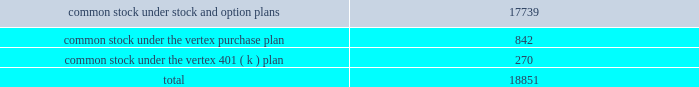"distribution date" ) .
Until the distribution date ( or earlier redemption or expiration of the rights ) , the rights will be traded with , and only with , the common stock .
Until a right is exercised , the right will not entitle the holder thereof to any rights as a stockholder .
If any person or group becomes an acquiring person , each holder of a right , other than rights beneficially owned by the acquiring person , will thereafter have the right to receive upon exercise and payment of the purchase price that number of shares of common stock having a market value of two times the purchase price and , if the company is acquired in a business combination transaction or 50% ( 50 % ) or more of its assets are sold , each holder of a right will thereafter have the right to receive upon exercise and payment of the purchase price that number of shares of common stock of the acquiring company which at the time of the transaction will have a market value of two times the purchase price .
At any time after any person becomes an acquiring person and prior to the acquisition by such person or group of 50% ( 50 % ) or more of the outstanding common stock , the board of directors of the company may cause the rights ( other than rights owned by such person or group ) to be exchanged , in whole or in part , for common stock or junior preferred shares , at an exchange rate of one share of common stock per right or one half of one-hundredth of a junior preferred share per right .
At any time prior to the acquisition by a person or group of beneficial ownership of 15% ( 15 % ) or more of the outstanding common stock , the board of directors of the company may redeem the rights at a price of $ 0.01 per right .
The rights have certain anti-takeover effects , in that they will cause substantial dilution to a person or group that attempts to acquire a significant interest in vertex on terms not approved by the board of directors .
Common stock reserved for future issuance at december 31 , 2005 , the company has reserved shares of common stock for future issuance under all equity compensation plans as follows ( shares in thousands ) : o .
Significant revenue arrangements the company has formed strategic collaborations with pharmaceutical companies and other organizations in the areas of drug discovery , development , and commercialization .
Research , development and commercialization agreements provide the company with financial support and other valuable resources for its research programs and for the development of clinical drug candidates , and the marketing and sales of products .
Collaborative research , development and commercialization agreements in the company's collaborative research , development and commercialization programs the company seeks to discover , develop and commercialize pharmaceutical products in conjunction with and supported by the company's collaborators .
Collaborative research and development arrangements may provide research funding over an initial contract period with renewal and termination options that .

What percent of the total common stock is under the vertex 401 ( k ) plan? 
Computations: (270 / 18851)
Answer: 0.01432. 